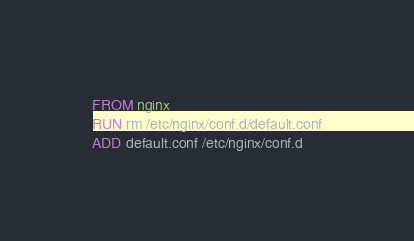Convert code to text. <code><loc_0><loc_0><loc_500><loc_500><_Dockerfile_>FROM nginx
RUN rm /etc/nginx/conf.d/default.conf
ADD default.conf /etc/nginx/conf.d
</code> 